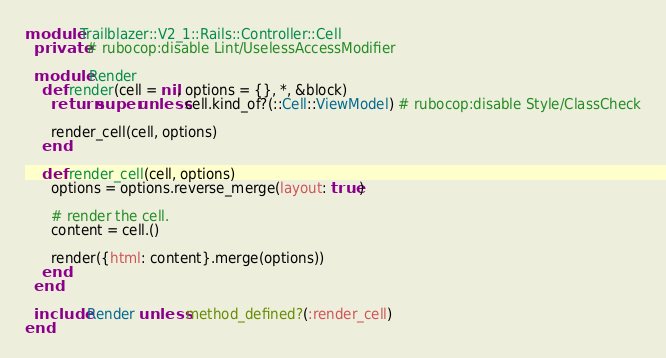<code> <loc_0><loc_0><loc_500><loc_500><_Ruby_>module Trailblazer::V2_1::Rails::Controller::Cell
  private # rubocop:disable Lint/UselessAccessModifier

  module Render
    def render(cell = nil, options = {}, *, &block)
      return super unless cell.kind_of?(::Cell::ViewModel) # rubocop:disable Style/ClassCheck

      render_cell(cell, options)
    end

    def render_cell(cell, options)
      options = options.reverse_merge(layout: true)

      # render the cell.
      content = cell.()

      render({html: content}.merge(options))
    end
  end

  include Render unless method_defined?(:render_cell)
end
</code> 